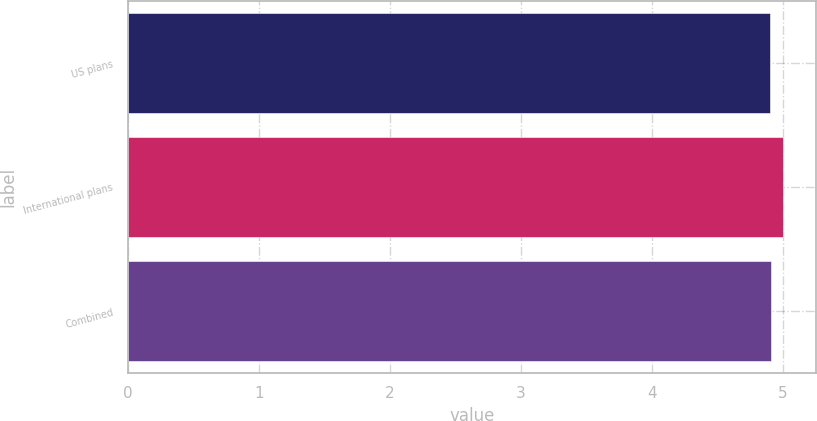Convert chart. <chart><loc_0><loc_0><loc_500><loc_500><bar_chart><fcel>US plans<fcel>International plans<fcel>Combined<nl><fcel>4.9<fcel>5<fcel>4.91<nl></chart> 